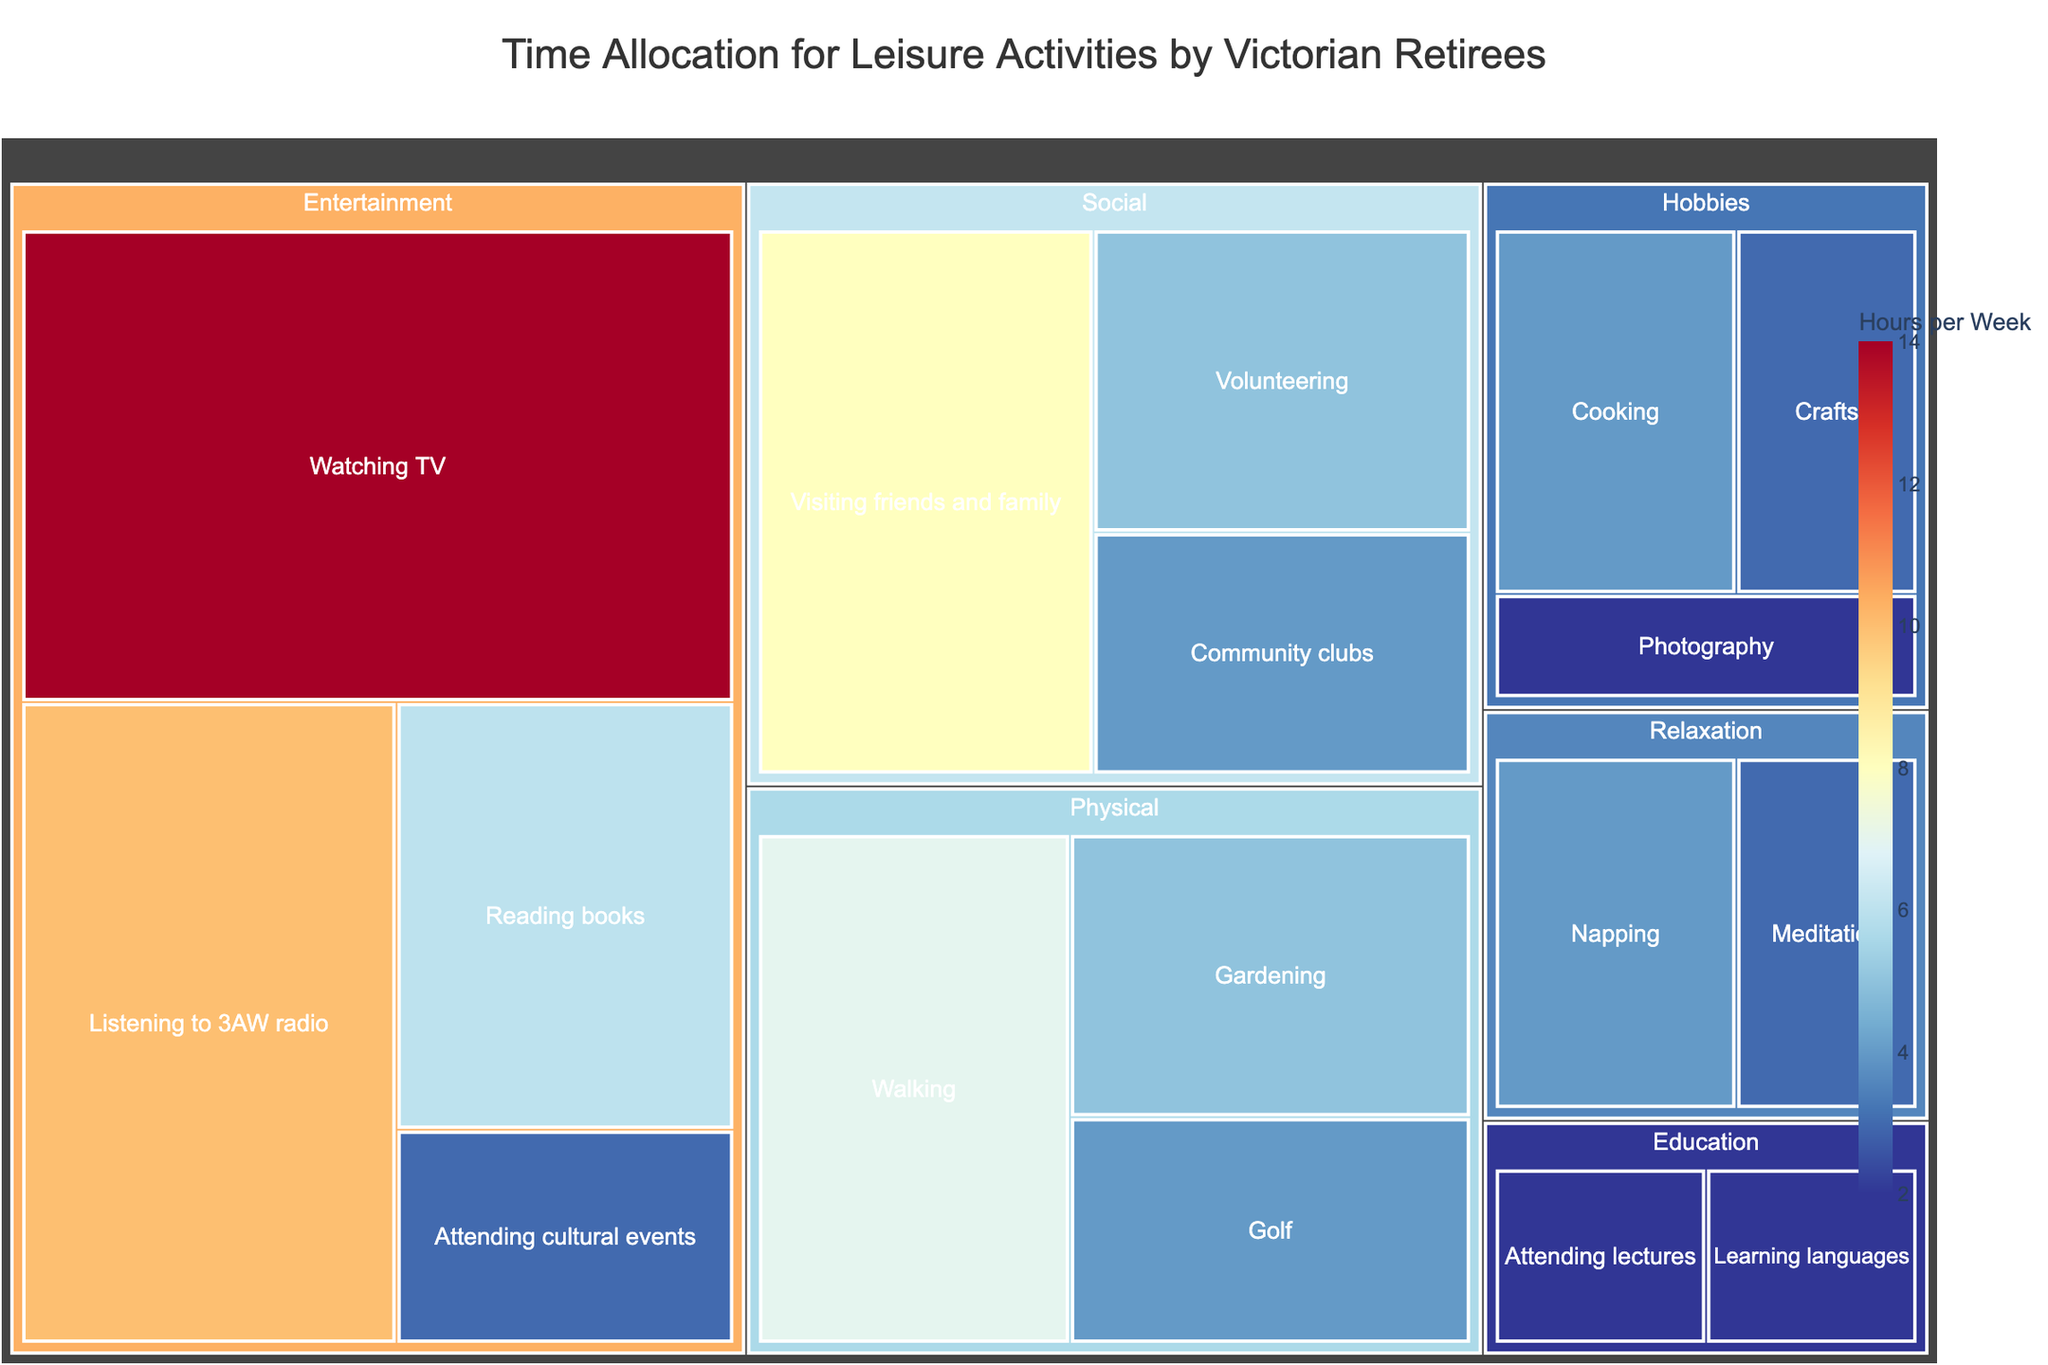What's the title of the figure? The title is prominently displayed at the top of the treemap, setting the context for the data shown.
Answer: Time Allocation for Leisure Activities by Victorian Retirees Which activity do retirees spend the most time on per week? The size of treemap tiles is proportional to the hours spent on each activity, and the largest tile corresponds to 'Watching TV'.
Answer: Watching TV What's the total time spent on social activities per week? Sum of the time spent on 'Visiting friends and family', 'Community clubs', and 'Volunteering' shown in the Social category. (8 + 4 + 5)
Answer: 17 hours Is more time spent on gardening or golf? Compare the sizes of the tiles for 'Gardening' and 'Golf' under the Physical category. The tile for 'Gardening' is larger.
Answer: Gardening Which activity under the Hobbies category has the least time allocated? Identify the smallest tile within the Hobbies category. 'Photography' has the smallest tile.
Answer: Photography How much more time is spent on listening to 3AW radio than reading books? Subtract the time spent on 'Reading books' from the time spent on 'Listening to 3AW radio' (10 - 6).
Answer: 4 hours What are the two activities with the same amount of time allocated? Look for tiles with the same size under different categories. Both 'Cooking' and 'Golf' have 4 hours per week.
Answer: Cooking and Golf What category has the tile with the least time spent on any activity? Scan through the smallest tiles of each category. The Educational category with 'Attending lectures' and 'Learning languages' has the smallest tiles with 2 hours each.
Answer: Education Which category contains the most activities? Count the number of activities listed under each category. The Entertainment category contains the most activities.
Answer: Entertainment Do retirees spend more time on hobbies or relaxation activities? Sum the times spent on all activities under Hobbies and compare with the sum of times under Relaxation. (Hobbies: 4+3+2=9, Relaxation: 3+4=7)
Answer: Hobbies 